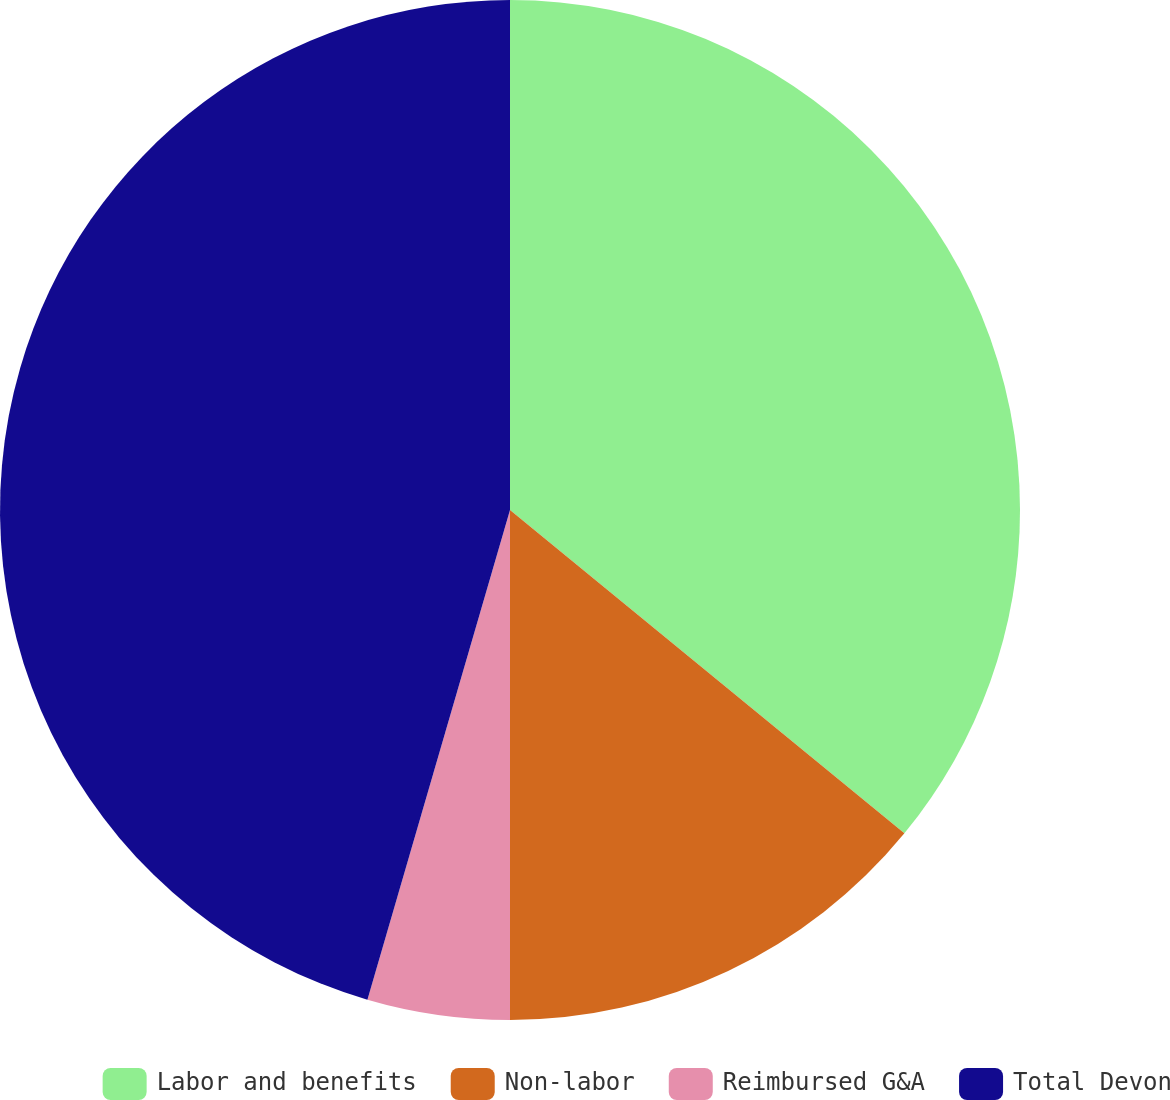Convert chart to OTSL. <chart><loc_0><loc_0><loc_500><loc_500><pie_chart><fcel>Labor and benefits<fcel>Non-labor<fcel>Reimbursed G&A<fcel>Total Devon<nl><fcel>35.93%<fcel>14.07%<fcel>4.51%<fcel>45.49%<nl></chart> 